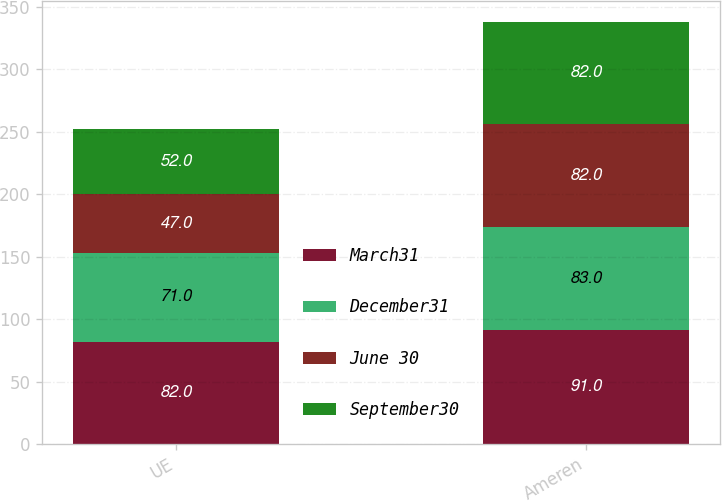<chart> <loc_0><loc_0><loc_500><loc_500><stacked_bar_chart><ecel><fcel>UE<fcel>Ameren<nl><fcel>March31<fcel>82<fcel>91<nl><fcel>December31<fcel>71<fcel>83<nl><fcel>June 30<fcel>47<fcel>82<nl><fcel>September30<fcel>52<fcel>82<nl></chart> 